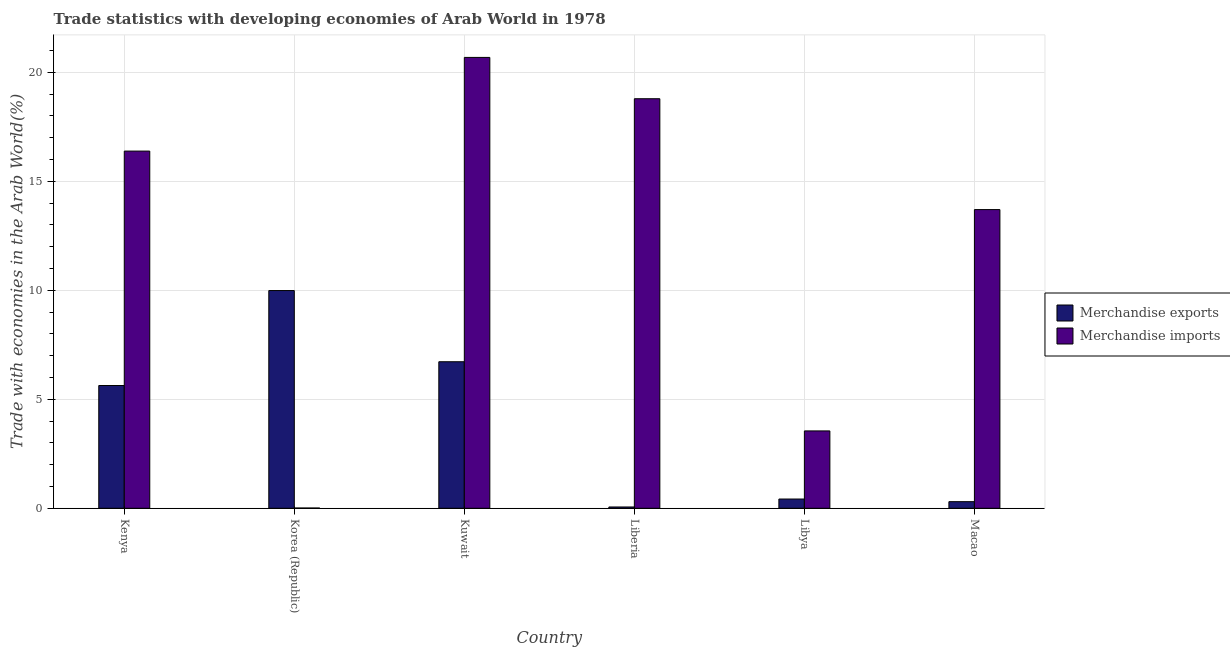How many different coloured bars are there?
Give a very brief answer. 2. Are the number of bars per tick equal to the number of legend labels?
Your response must be concise. Yes. How many bars are there on the 4th tick from the left?
Your answer should be compact. 2. How many bars are there on the 2nd tick from the right?
Your response must be concise. 2. What is the label of the 2nd group of bars from the left?
Your answer should be very brief. Korea (Republic). In how many cases, is the number of bars for a given country not equal to the number of legend labels?
Your response must be concise. 0. What is the merchandise imports in Liberia?
Keep it short and to the point. 18.78. Across all countries, what is the maximum merchandise exports?
Provide a short and direct response. 9.99. Across all countries, what is the minimum merchandise imports?
Your answer should be compact. 0.01. In which country was the merchandise imports maximum?
Give a very brief answer. Kuwait. What is the total merchandise exports in the graph?
Give a very brief answer. 23.12. What is the difference between the merchandise exports in Korea (Republic) and that in Libya?
Your response must be concise. 9.56. What is the difference between the merchandise imports in Korea (Republic) and the merchandise exports in Libya?
Ensure brevity in your answer.  -0.41. What is the average merchandise exports per country?
Provide a short and direct response. 3.85. What is the difference between the merchandise imports and merchandise exports in Macao?
Provide a short and direct response. 13.4. In how many countries, is the merchandise imports greater than 4 %?
Provide a succinct answer. 4. What is the ratio of the merchandise exports in Kenya to that in Kuwait?
Keep it short and to the point. 0.84. Is the merchandise exports in Korea (Republic) less than that in Macao?
Offer a terse response. No. What is the difference between the highest and the second highest merchandise imports?
Make the answer very short. 1.89. What is the difference between the highest and the lowest merchandise imports?
Make the answer very short. 20.67. Is the sum of the merchandise imports in Kuwait and Liberia greater than the maximum merchandise exports across all countries?
Provide a short and direct response. Yes. What does the 1st bar from the left in Korea (Republic) represents?
Offer a very short reply. Merchandise exports. What does the 1st bar from the right in Libya represents?
Keep it short and to the point. Merchandise imports. Are all the bars in the graph horizontal?
Your answer should be compact. No. How many countries are there in the graph?
Offer a very short reply. 6. What is the difference between two consecutive major ticks on the Y-axis?
Your response must be concise. 5. Are the values on the major ticks of Y-axis written in scientific E-notation?
Make the answer very short. No. Does the graph contain any zero values?
Keep it short and to the point. No. Does the graph contain grids?
Your answer should be compact. Yes. Where does the legend appear in the graph?
Provide a short and direct response. Center right. How many legend labels are there?
Offer a very short reply. 2. How are the legend labels stacked?
Your response must be concise. Vertical. What is the title of the graph?
Make the answer very short. Trade statistics with developing economies of Arab World in 1978. Does "Nonresident" appear as one of the legend labels in the graph?
Your answer should be compact. No. What is the label or title of the Y-axis?
Offer a terse response. Trade with economies in the Arab World(%). What is the Trade with economies in the Arab World(%) in Merchandise exports in Kenya?
Give a very brief answer. 5.63. What is the Trade with economies in the Arab World(%) in Merchandise imports in Kenya?
Ensure brevity in your answer.  16.38. What is the Trade with economies in the Arab World(%) of Merchandise exports in Korea (Republic)?
Your response must be concise. 9.99. What is the Trade with economies in the Arab World(%) in Merchandise imports in Korea (Republic)?
Your answer should be compact. 0.01. What is the Trade with economies in the Arab World(%) of Merchandise exports in Kuwait?
Offer a terse response. 6.72. What is the Trade with economies in the Arab World(%) in Merchandise imports in Kuwait?
Offer a terse response. 20.68. What is the Trade with economies in the Arab World(%) of Merchandise exports in Liberia?
Keep it short and to the point. 0.06. What is the Trade with economies in the Arab World(%) of Merchandise imports in Liberia?
Your answer should be very brief. 18.78. What is the Trade with economies in the Arab World(%) in Merchandise exports in Libya?
Your response must be concise. 0.42. What is the Trade with economies in the Arab World(%) of Merchandise imports in Libya?
Offer a very short reply. 3.55. What is the Trade with economies in the Arab World(%) of Merchandise exports in Macao?
Provide a succinct answer. 0.3. What is the Trade with economies in the Arab World(%) in Merchandise imports in Macao?
Provide a succinct answer. 13.7. Across all countries, what is the maximum Trade with economies in the Arab World(%) of Merchandise exports?
Offer a terse response. 9.99. Across all countries, what is the maximum Trade with economies in the Arab World(%) in Merchandise imports?
Offer a terse response. 20.68. Across all countries, what is the minimum Trade with economies in the Arab World(%) in Merchandise exports?
Provide a succinct answer. 0.06. Across all countries, what is the minimum Trade with economies in the Arab World(%) of Merchandise imports?
Keep it short and to the point. 0.01. What is the total Trade with economies in the Arab World(%) in Merchandise exports in the graph?
Your answer should be very brief. 23.12. What is the total Trade with economies in the Arab World(%) in Merchandise imports in the graph?
Your response must be concise. 73.11. What is the difference between the Trade with economies in the Arab World(%) in Merchandise exports in Kenya and that in Korea (Republic)?
Your response must be concise. -4.36. What is the difference between the Trade with economies in the Arab World(%) in Merchandise imports in Kenya and that in Korea (Republic)?
Your answer should be very brief. 16.37. What is the difference between the Trade with economies in the Arab World(%) in Merchandise exports in Kenya and that in Kuwait?
Offer a terse response. -1.09. What is the difference between the Trade with economies in the Arab World(%) of Merchandise imports in Kenya and that in Kuwait?
Ensure brevity in your answer.  -4.3. What is the difference between the Trade with economies in the Arab World(%) of Merchandise exports in Kenya and that in Liberia?
Give a very brief answer. 5.57. What is the difference between the Trade with economies in the Arab World(%) of Merchandise imports in Kenya and that in Liberia?
Give a very brief answer. -2.4. What is the difference between the Trade with economies in the Arab World(%) in Merchandise exports in Kenya and that in Libya?
Provide a short and direct response. 5.21. What is the difference between the Trade with economies in the Arab World(%) of Merchandise imports in Kenya and that in Libya?
Provide a succinct answer. 12.84. What is the difference between the Trade with economies in the Arab World(%) in Merchandise exports in Kenya and that in Macao?
Make the answer very short. 5.33. What is the difference between the Trade with economies in the Arab World(%) of Merchandise imports in Kenya and that in Macao?
Your response must be concise. 2.68. What is the difference between the Trade with economies in the Arab World(%) of Merchandise exports in Korea (Republic) and that in Kuwait?
Your answer should be very brief. 3.26. What is the difference between the Trade with economies in the Arab World(%) of Merchandise imports in Korea (Republic) and that in Kuwait?
Keep it short and to the point. -20.67. What is the difference between the Trade with economies in the Arab World(%) of Merchandise exports in Korea (Republic) and that in Liberia?
Ensure brevity in your answer.  9.93. What is the difference between the Trade with economies in the Arab World(%) in Merchandise imports in Korea (Republic) and that in Liberia?
Offer a terse response. -18.77. What is the difference between the Trade with economies in the Arab World(%) in Merchandise exports in Korea (Republic) and that in Libya?
Provide a succinct answer. 9.56. What is the difference between the Trade with economies in the Arab World(%) in Merchandise imports in Korea (Republic) and that in Libya?
Your response must be concise. -3.54. What is the difference between the Trade with economies in the Arab World(%) in Merchandise exports in Korea (Republic) and that in Macao?
Your response must be concise. 9.68. What is the difference between the Trade with economies in the Arab World(%) in Merchandise imports in Korea (Republic) and that in Macao?
Provide a succinct answer. -13.69. What is the difference between the Trade with economies in the Arab World(%) in Merchandise exports in Kuwait and that in Liberia?
Provide a succinct answer. 6.66. What is the difference between the Trade with economies in the Arab World(%) in Merchandise imports in Kuwait and that in Liberia?
Make the answer very short. 1.89. What is the difference between the Trade with economies in the Arab World(%) in Merchandise exports in Kuwait and that in Libya?
Offer a very short reply. 6.3. What is the difference between the Trade with economies in the Arab World(%) of Merchandise imports in Kuwait and that in Libya?
Offer a very short reply. 17.13. What is the difference between the Trade with economies in the Arab World(%) in Merchandise exports in Kuwait and that in Macao?
Offer a terse response. 6.42. What is the difference between the Trade with economies in the Arab World(%) in Merchandise imports in Kuwait and that in Macao?
Provide a short and direct response. 6.98. What is the difference between the Trade with economies in the Arab World(%) of Merchandise exports in Liberia and that in Libya?
Your answer should be compact. -0.36. What is the difference between the Trade with economies in the Arab World(%) in Merchandise imports in Liberia and that in Libya?
Offer a terse response. 15.24. What is the difference between the Trade with economies in the Arab World(%) in Merchandise exports in Liberia and that in Macao?
Ensure brevity in your answer.  -0.24. What is the difference between the Trade with economies in the Arab World(%) of Merchandise imports in Liberia and that in Macao?
Offer a very short reply. 5.08. What is the difference between the Trade with economies in the Arab World(%) in Merchandise exports in Libya and that in Macao?
Your response must be concise. 0.12. What is the difference between the Trade with economies in the Arab World(%) in Merchandise imports in Libya and that in Macao?
Your answer should be compact. -10.15. What is the difference between the Trade with economies in the Arab World(%) of Merchandise exports in Kenya and the Trade with economies in the Arab World(%) of Merchandise imports in Korea (Republic)?
Offer a very short reply. 5.62. What is the difference between the Trade with economies in the Arab World(%) in Merchandise exports in Kenya and the Trade with economies in the Arab World(%) in Merchandise imports in Kuwait?
Provide a succinct answer. -15.05. What is the difference between the Trade with economies in the Arab World(%) of Merchandise exports in Kenya and the Trade with economies in the Arab World(%) of Merchandise imports in Liberia?
Give a very brief answer. -13.15. What is the difference between the Trade with economies in the Arab World(%) in Merchandise exports in Kenya and the Trade with economies in the Arab World(%) in Merchandise imports in Libya?
Offer a very short reply. 2.08. What is the difference between the Trade with economies in the Arab World(%) in Merchandise exports in Kenya and the Trade with economies in the Arab World(%) in Merchandise imports in Macao?
Your response must be concise. -8.07. What is the difference between the Trade with economies in the Arab World(%) of Merchandise exports in Korea (Republic) and the Trade with economies in the Arab World(%) of Merchandise imports in Kuwait?
Provide a succinct answer. -10.69. What is the difference between the Trade with economies in the Arab World(%) in Merchandise exports in Korea (Republic) and the Trade with economies in the Arab World(%) in Merchandise imports in Liberia?
Offer a very short reply. -8.8. What is the difference between the Trade with economies in the Arab World(%) of Merchandise exports in Korea (Republic) and the Trade with economies in the Arab World(%) of Merchandise imports in Libya?
Keep it short and to the point. 6.44. What is the difference between the Trade with economies in the Arab World(%) of Merchandise exports in Korea (Republic) and the Trade with economies in the Arab World(%) of Merchandise imports in Macao?
Your answer should be very brief. -3.71. What is the difference between the Trade with economies in the Arab World(%) of Merchandise exports in Kuwait and the Trade with economies in the Arab World(%) of Merchandise imports in Liberia?
Ensure brevity in your answer.  -12.06. What is the difference between the Trade with economies in the Arab World(%) of Merchandise exports in Kuwait and the Trade with economies in the Arab World(%) of Merchandise imports in Libya?
Provide a short and direct response. 3.17. What is the difference between the Trade with economies in the Arab World(%) of Merchandise exports in Kuwait and the Trade with economies in the Arab World(%) of Merchandise imports in Macao?
Provide a short and direct response. -6.98. What is the difference between the Trade with economies in the Arab World(%) in Merchandise exports in Liberia and the Trade with economies in the Arab World(%) in Merchandise imports in Libya?
Offer a terse response. -3.49. What is the difference between the Trade with economies in the Arab World(%) in Merchandise exports in Liberia and the Trade with economies in the Arab World(%) in Merchandise imports in Macao?
Provide a short and direct response. -13.64. What is the difference between the Trade with economies in the Arab World(%) of Merchandise exports in Libya and the Trade with economies in the Arab World(%) of Merchandise imports in Macao?
Your response must be concise. -13.28. What is the average Trade with economies in the Arab World(%) in Merchandise exports per country?
Keep it short and to the point. 3.85. What is the average Trade with economies in the Arab World(%) of Merchandise imports per country?
Make the answer very short. 12.18. What is the difference between the Trade with economies in the Arab World(%) in Merchandise exports and Trade with economies in the Arab World(%) in Merchandise imports in Kenya?
Provide a succinct answer. -10.75. What is the difference between the Trade with economies in the Arab World(%) of Merchandise exports and Trade with economies in the Arab World(%) of Merchandise imports in Korea (Republic)?
Your answer should be compact. 9.97. What is the difference between the Trade with economies in the Arab World(%) in Merchandise exports and Trade with economies in the Arab World(%) in Merchandise imports in Kuwait?
Make the answer very short. -13.96. What is the difference between the Trade with economies in the Arab World(%) of Merchandise exports and Trade with economies in the Arab World(%) of Merchandise imports in Liberia?
Your answer should be very brief. -18.73. What is the difference between the Trade with economies in the Arab World(%) of Merchandise exports and Trade with economies in the Arab World(%) of Merchandise imports in Libya?
Your answer should be very brief. -3.12. What is the difference between the Trade with economies in the Arab World(%) of Merchandise exports and Trade with economies in the Arab World(%) of Merchandise imports in Macao?
Keep it short and to the point. -13.4. What is the ratio of the Trade with economies in the Arab World(%) of Merchandise exports in Kenya to that in Korea (Republic)?
Make the answer very short. 0.56. What is the ratio of the Trade with economies in the Arab World(%) in Merchandise imports in Kenya to that in Korea (Republic)?
Provide a succinct answer. 1402.98. What is the ratio of the Trade with economies in the Arab World(%) in Merchandise exports in Kenya to that in Kuwait?
Give a very brief answer. 0.84. What is the ratio of the Trade with economies in the Arab World(%) in Merchandise imports in Kenya to that in Kuwait?
Offer a very short reply. 0.79. What is the ratio of the Trade with economies in the Arab World(%) in Merchandise exports in Kenya to that in Liberia?
Your answer should be compact. 94.72. What is the ratio of the Trade with economies in the Arab World(%) in Merchandise imports in Kenya to that in Liberia?
Keep it short and to the point. 0.87. What is the ratio of the Trade with economies in the Arab World(%) of Merchandise exports in Kenya to that in Libya?
Provide a short and direct response. 13.28. What is the ratio of the Trade with economies in the Arab World(%) of Merchandise imports in Kenya to that in Libya?
Keep it short and to the point. 4.62. What is the ratio of the Trade with economies in the Arab World(%) in Merchandise exports in Kenya to that in Macao?
Your answer should be very brief. 18.58. What is the ratio of the Trade with economies in the Arab World(%) of Merchandise imports in Kenya to that in Macao?
Provide a short and direct response. 1.2. What is the ratio of the Trade with economies in the Arab World(%) of Merchandise exports in Korea (Republic) to that in Kuwait?
Give a very brief answer. 1.49. What is the ratio of the Trade with economies in the Arab World(%) in Merchandise imports in Korea (Republic) to that in Kuwait?
Provide a succinct answer. 0. What is the ratio of the Trade with economies in the Arab World(%) of Merchandise exports in Korea (Republic) to that in Liberia?
Your answer should be compact. 168. What is the ratio of the Trade with economies in the Arab World(%) in Merchandise imports in Korea (Republic) to that in Liberia?
Make the answer very short. 0. What is the ratio of the Trade with economies in the Arab World(%) in Merchandise exports in Korea (Republic) to that in Libya?
Give a very brief answer. 23.55. What is the ratio of the Trade with economies in the Arab World(%) in Merchandise imports in Korea (Republic) to that in Libya?
Your response must be concise. 0. What is the ratio of the Trade with economies in the Arab World(%) of Merchandise exports in Korea (Republic) to that in Macao?
Provide a short and direct response. 32.95. What is the ratio of the Trade with economies in the Arab World(%) in Merchandise imports in Korea (Republic) to that in Macao?
Provide a short and direct response. 0. What is the ratio of the Trade with economies in the Arab World(%) of Merchandise exports in Kuwait to that in Liberia?
Your answer should be very brief. 113.07. What is the ratio of the Trade with economies in the Arab World(%) in Merchandise imports in Kuwait to that in Liberia?
Offer a very short reply. 1.1. What is the ratio of the Trade with economies in the Arab World(%) in Merchandise exports in Kuwait to that in Libya?
Your answer should be very brief. 15.85. What is the ratio of the Trade with economies in the Arab World(%) in Merchandise imports in Kuwait to that in Libya?
Your answer should be compact. 5.83. What is the ratio of the Trade with economies in the Arab World(%) in Merchandise exports in Kuwait to that in Macao?
Provide a short and direct response. 22.18. What is the ratio of the Trade with economies in the Arab World(%) of Merchandise imports in Kuwait to that in Macao?
Make the answer very short. 1.51. What is the ratio of the Trade with economies in the Arab World(%) in Merchandise exports in Liberia to that in Libya?
Your response must be concise. 0.14. What is the ratio of the Trade with economies in the Arab World(%) in Merchandise imports in Liberia to that in Libya?
Your answer should be compact. 5.29. What is the ratio of the Trade with economies in the Arab World(%) in Merchandise exports in Liberia to that in Macao?
Ensure brevity in your answer.  0.2. What is the ratio of the Trade with economies in the Arab World(%) of Merchandise imports in Liberia to that in Macao?
Ensure brevity in your answer.  1.37. What is the ratio of the Trade with economies in the Arab World(%) in Merchandise exports in Libya to that in Macao?
Make the answer very short. 1.4. What is the ratio of the Trade with economies in the Arab World(%) of Merchandise imports in Libya to that in Macao?
Provide a succinct answer. 0.26. What is the difference between the highest and the second highest Trade with economies in the Arab World(%) of Merchandise exports?
Make the answer very short. 3.26. What is the difference between the highest and the second highest Trade with economies in the Arab World(%) in Merchandise imports?
Your answer should be compact. 1.89. What is the difference between the highest and the lowest Trade with economies in the Arab World(%) of Merchandise exports?
Keep it short and to the point. 9.93. What is the difference between the highest and the lowest Trade with economies in the Arab World(%) in Merchandise imports?
Your answer should be very brief. 20.67. 